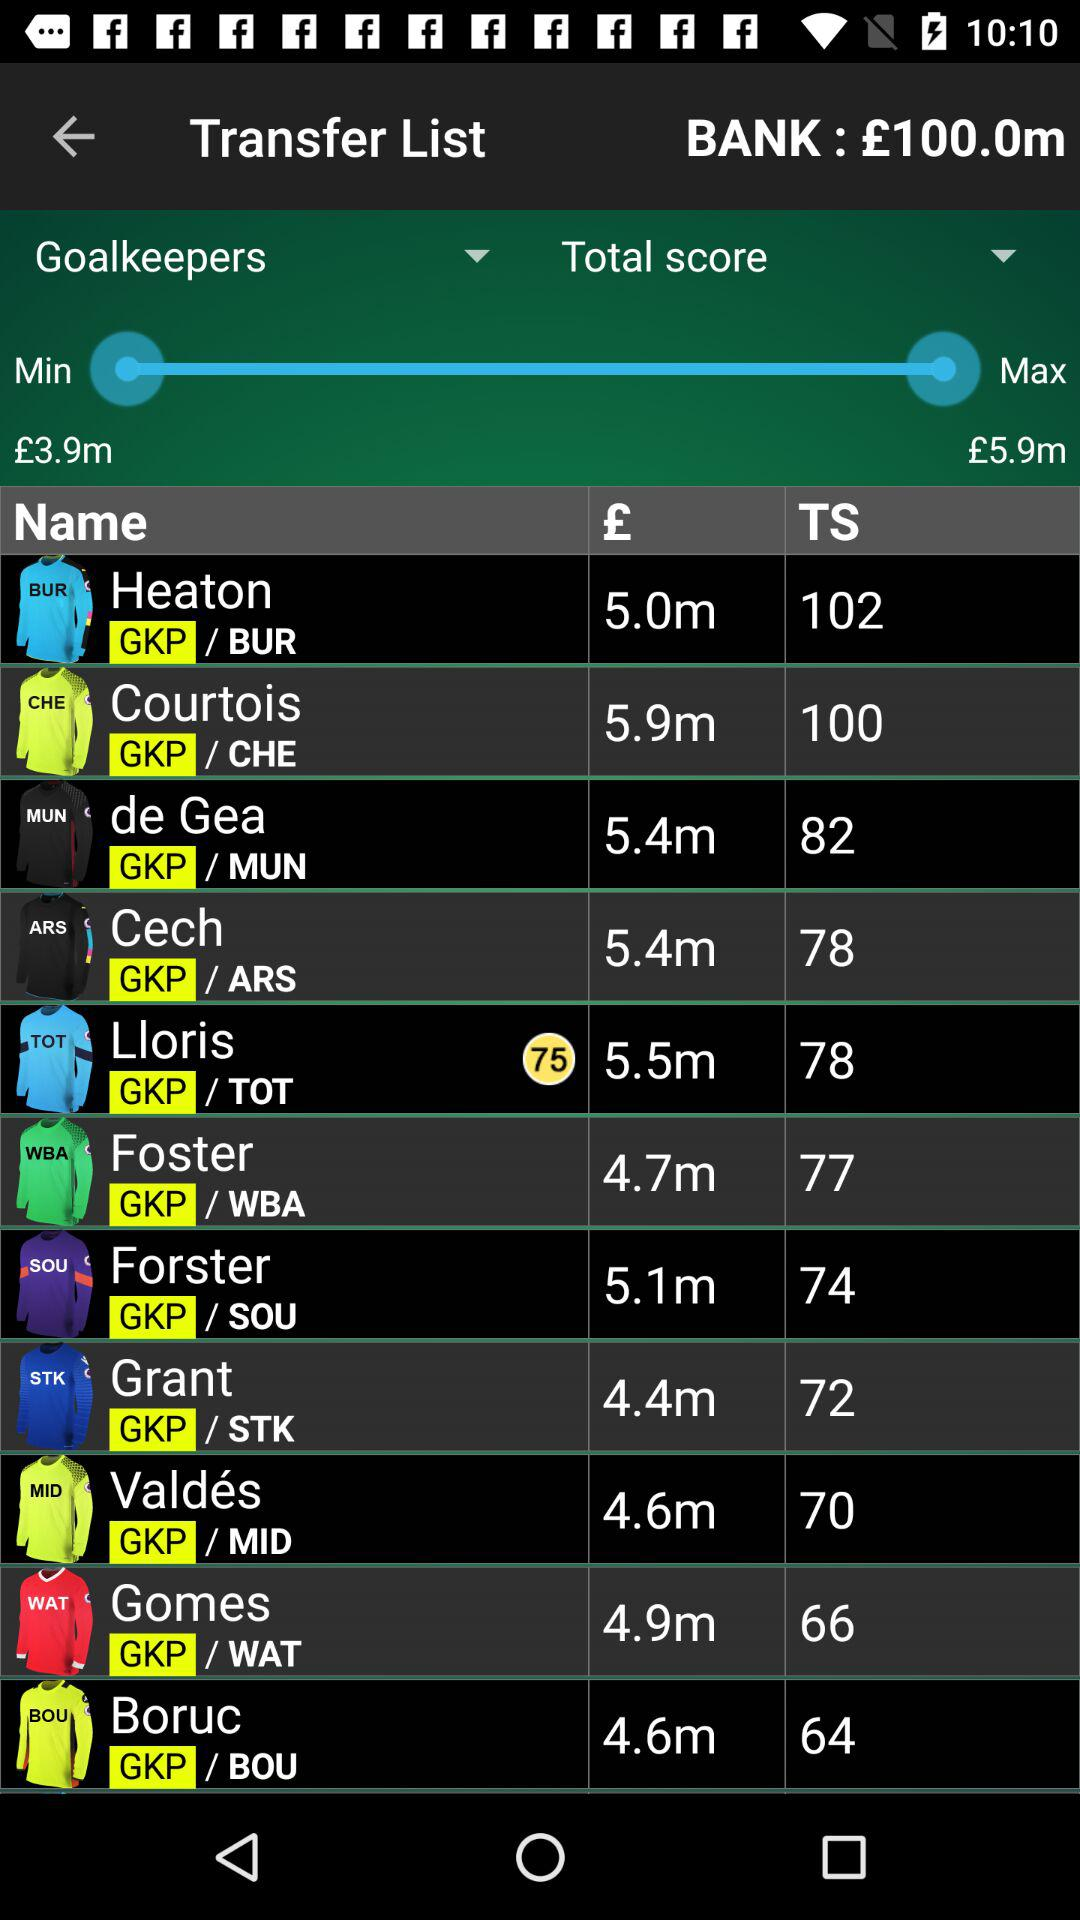What's the total amount in the bank? The total amount is £100m. 